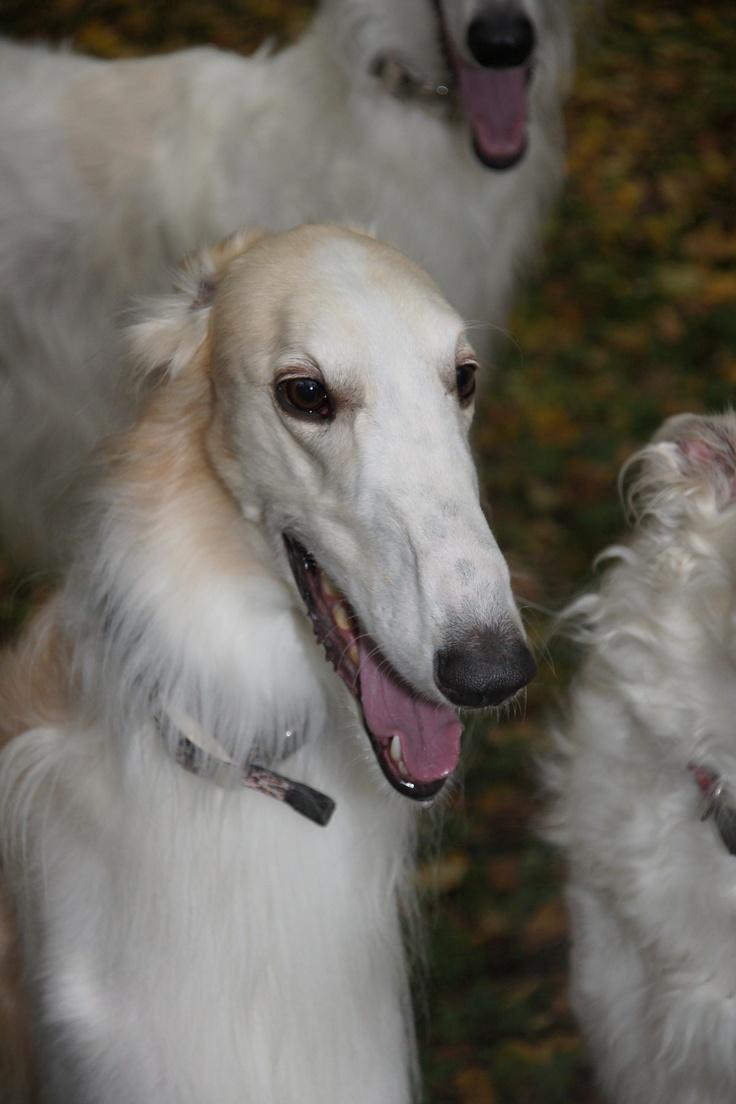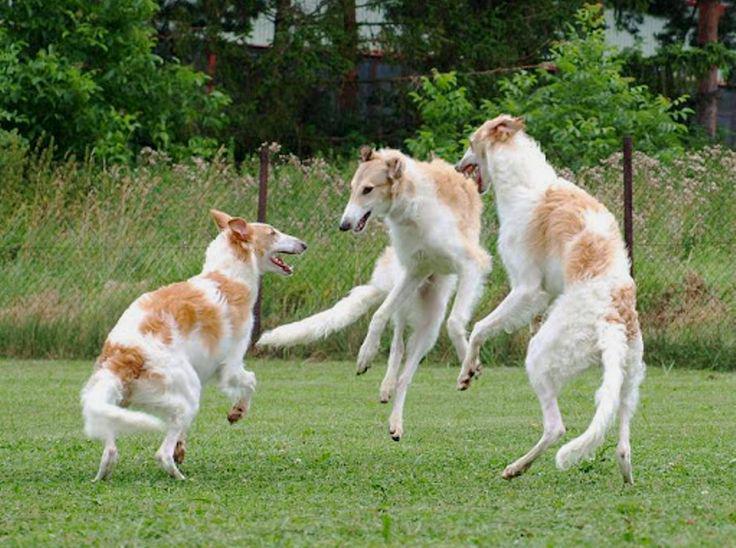The first image is the image on the left, the second image is the image on the right. For the images displayed, is the sentence "An image shows a human hand next to the head of a hound posed in front of ornate architecture." factually correct? Answer yes or no. No. The first image is the image on the left, the second image is the image on the right. Analyze the images presented: Is the assertion "One image shows at least one large dog with a handler at a majestic building, while the other image of at least two dogs is set in a rustic outdoor area." valid? Answer yes or no. No. 